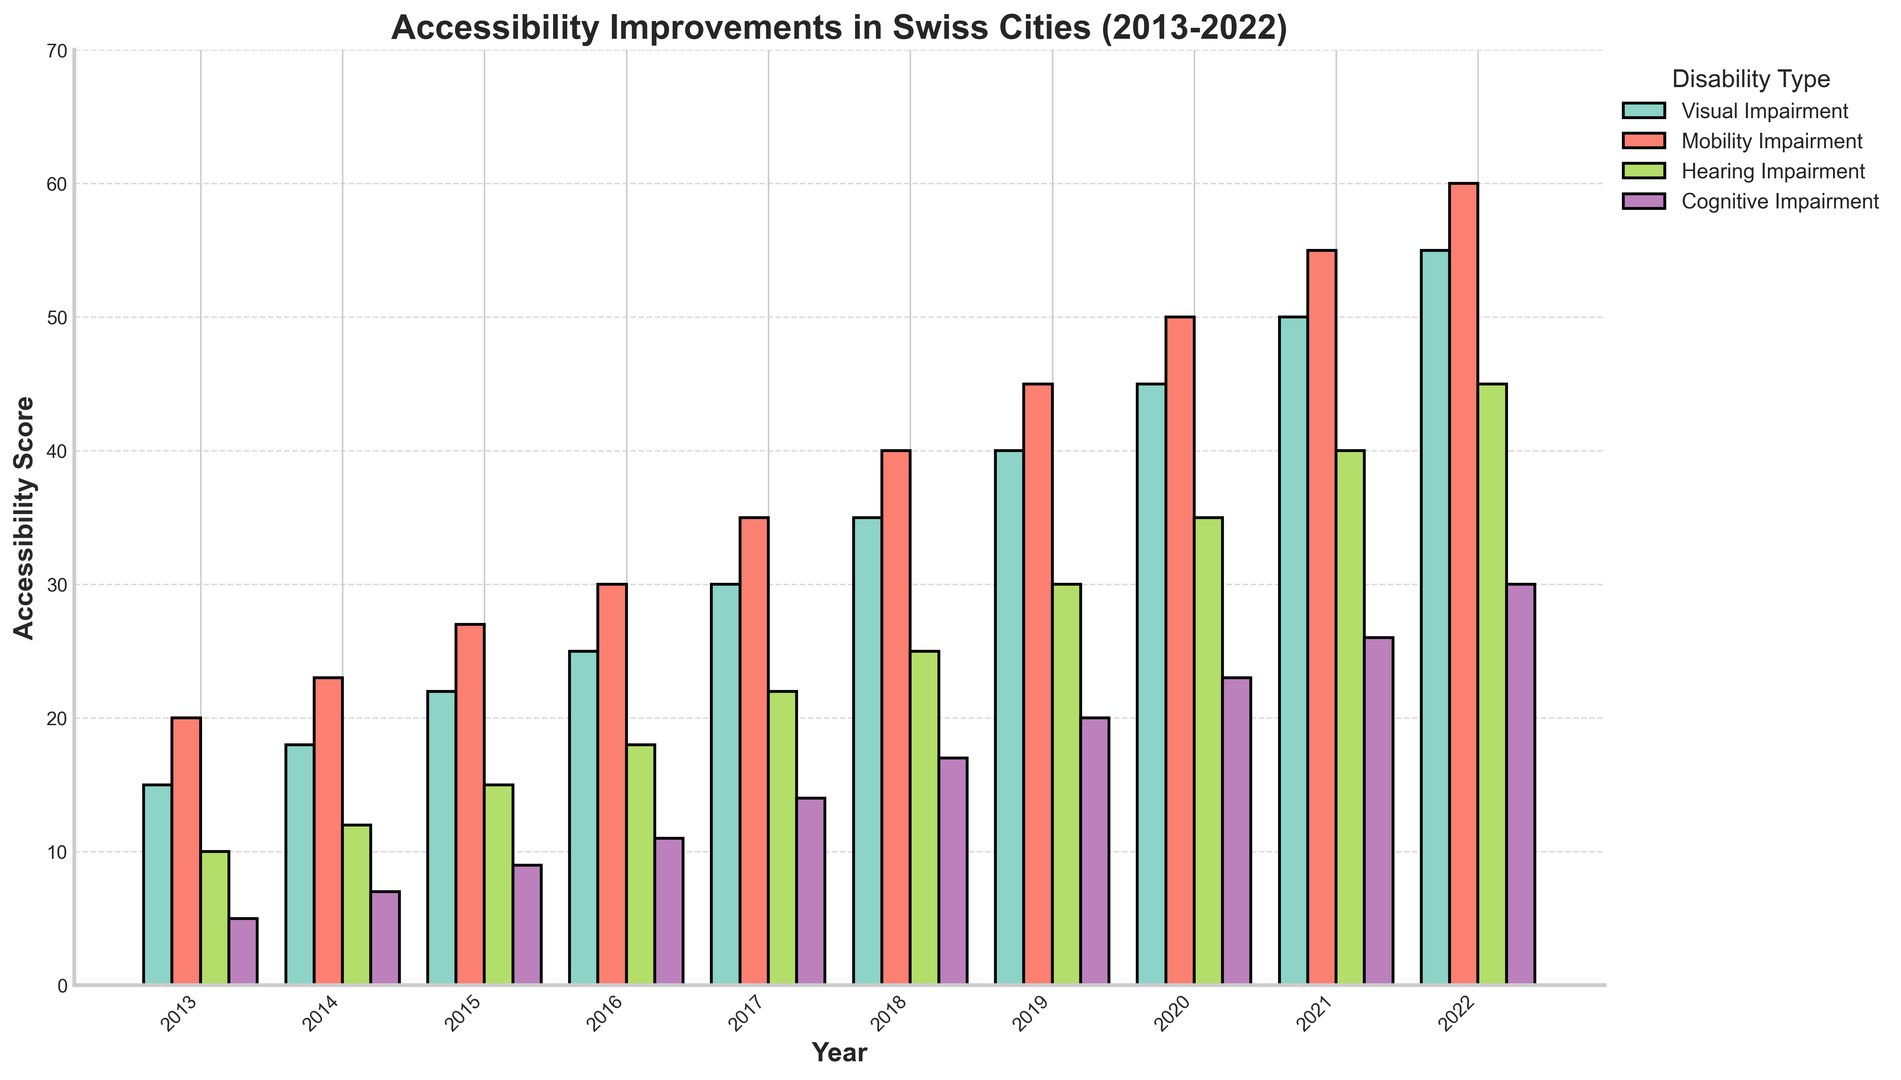What year saw the highest improvement for Mobility Impairment? The year with the highest improvement for Mobility Impairment is identified by looking at the bar with the greatest height in the Mobility Impairment category. The tallest bar for Mobility Impairment is labeled 2022.
Answer: 2022 Which disability type had the least improvement in 2013? To find this, look at the four bars for 2013 and identify the shortest one. The shortest bar for 2013 corresponds to Cognitive Impairment which has the lowest value.
Answer: Cognitive Impairment What was the overall trend observed in Visual Impairment from 2013 to 2022? Observing the bars for Visual Impairment from 2013 to 2022, they show a consistent upward trend, increasing in height each year.
Answer: Increasing How much did the accessibility score for Hearing Impairment increase from 2017 to 2022? To calculate the increase, find the score for Hearing Impairment in 2022 and subtract the score from 2017. The scores are 45 (2022) and 22 (2017), resulting in an increase of 45 - 22 = 23.
Answer: 23 Which year had an equal number of improvements for Mobility Impairment and Hearing Impairment? This requires comparing the heights of the bars for these two categories across all years. In no year do the bars for Mobility Impairment and Hearing Impairment have the same height.
Answer: None Comparing Visual Impairment and Cognitive Impairment in 2020, which had the higher score and by how much? Check the heights of the bars for Visual Impairment and Cognitive Impairment in 2020. Visual Impairment is 45 and Cognitive Impairment is 23, hence Visual Impairment is higher by 45 - 23 = 22.
Answer: Visual Impairment by 22 By how many points did Cognitive Impairment improve from 2014 to 2015, and from 2015 to 2016? The score for Cognitive Impairment in 2014 is 7, in 2015 it is 9, and in 2016 it is 11. The difference between 2014 and 2015 is 9 - 7 = 2, and between 2015 and 2016 is 11 - 9 = 2.
Answer: 2, 2 Describe the change in accessibility scores for Hearing Impairment between 2014 and 2016. Reading the bar heights for Hearing Impairment, the scores are 12 in 2014, 15 in 2015, and 18 in 2016, showing a consistent increase each year: 15 - 12 = 3 and 18 - 15 = 3.
Answer: Increased, 3 points each year Which disability type showed the largest improvement from 2013 to 2022? By comparing the improvements for each category from 2013 to 2022, Visual Impairment showed the largest increase from a score of 15 to 55, which is an increase of 40 points.
Answer: Visual Impairment 